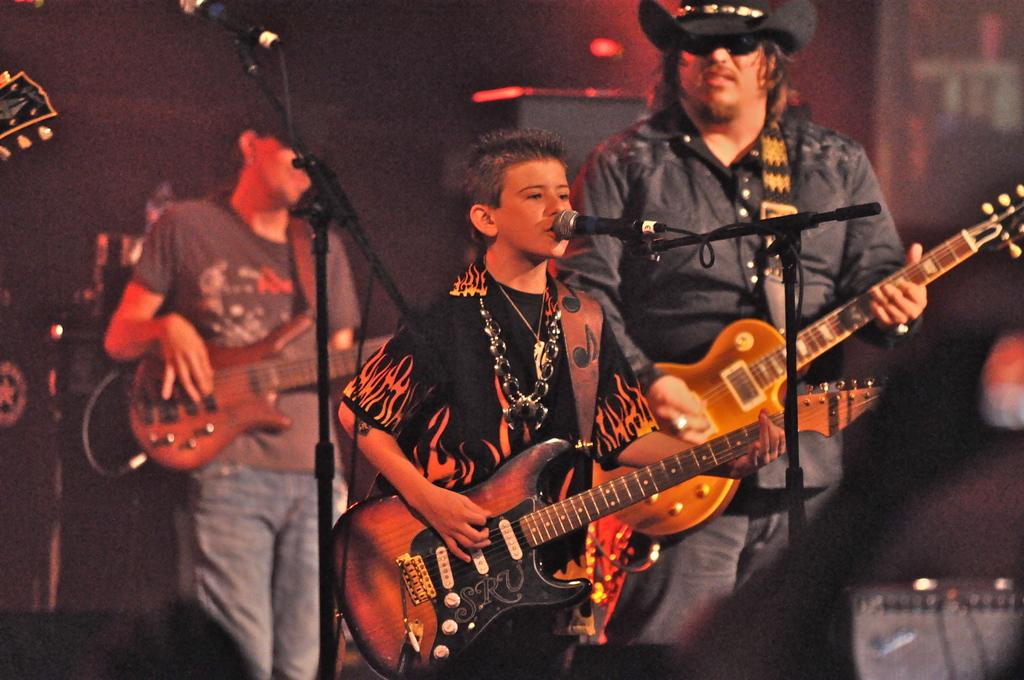What event is taking place in the image? The image is taken at a concert. How many people are in the image? There are three people in the image. What are the people doing in the image? The people are standing and holding guitars, and they are singing with microphones. What can be seen in the background of the image? There is a wall in the background of the image. What type of bear can be seen in the image? There is no bear present in the image; it is a concert scene with people holding guitars and singing. How does the earth affect the performance in the image? The image does not show any direct impact of the earth on the performance; it is an indoor concert scene. 